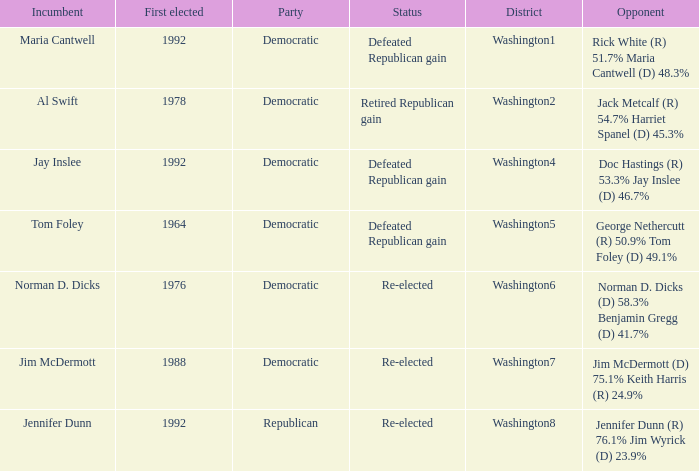What was the result of the election of doc hastings (r) 53.3% jay inslee (d) 46.7% Defeated Republican gain. 